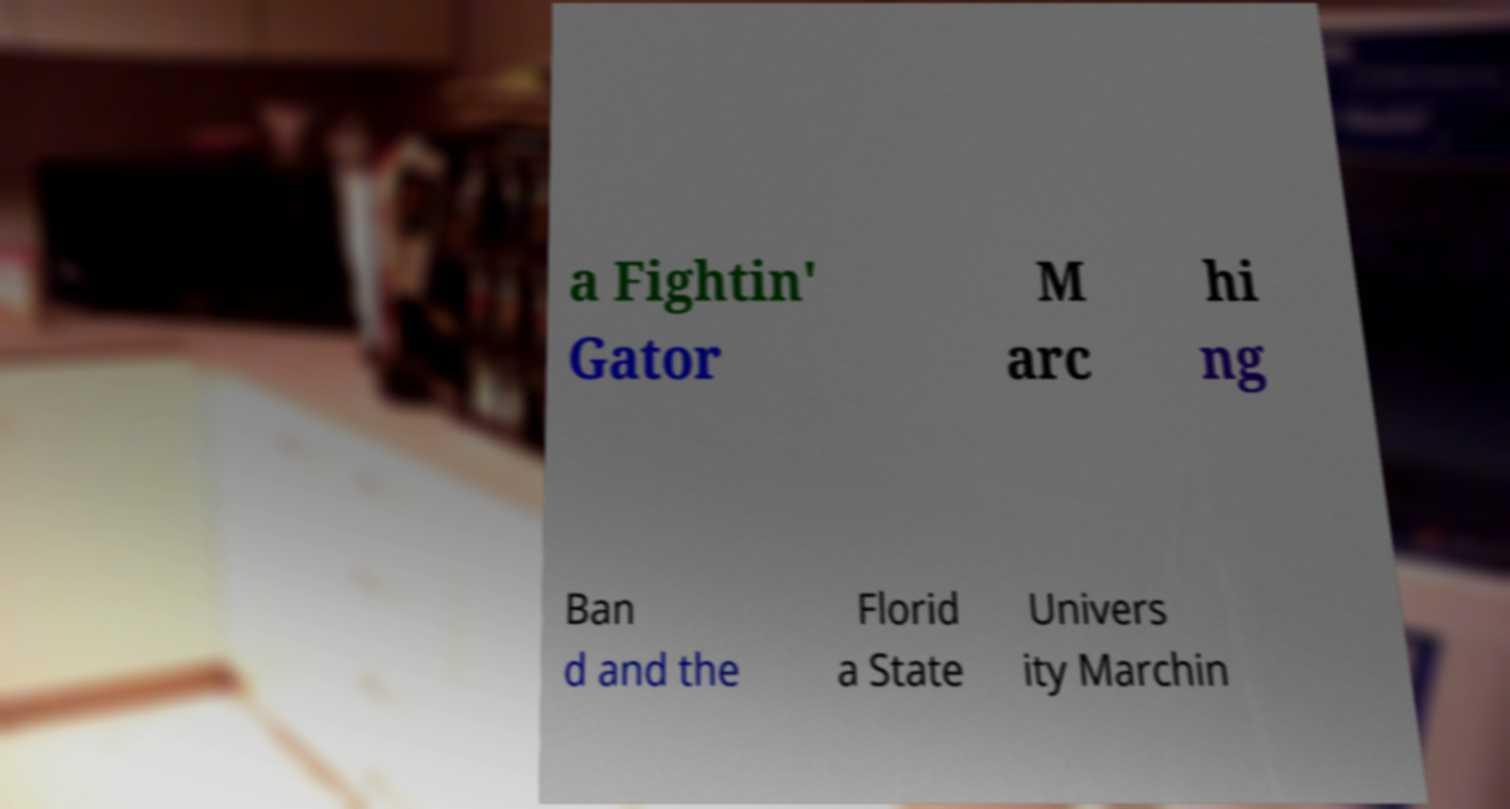I need the written content from this picture converted into text. Can you do that? a Fightin' Gator M arc hi ng Ban d and the Florid a State Univers ity Marchin 